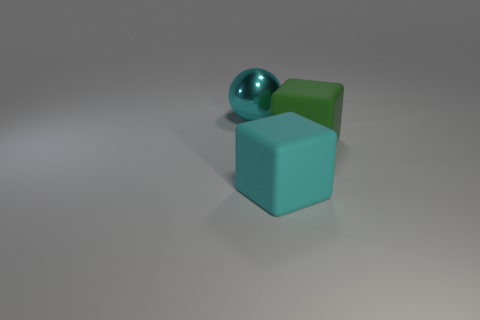Are there any other things that have the same shape as the green rubber thing? In everyday life, numerous objects can have a similar shape to the green rubber item in the image, which appears to be a cube. Some common examples include dice, toy blocks, sugar cubes, or even packing boxes. These all share the cube's six equal square faces and all meet at ninety-degree angles. 